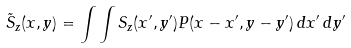<formula> <loc_0><loc_0><loc_500><loc_500>\tilde { S } _ { z } ( x , y ) = \int \int S _ { z } ( x ^ { \prime } , y ^ { \prime } ) P ( x - x ^ { \prime } , y - y ^ { \prime } ) \, d x ^ { \prime } \, d y ^ { \prime }</formula> 